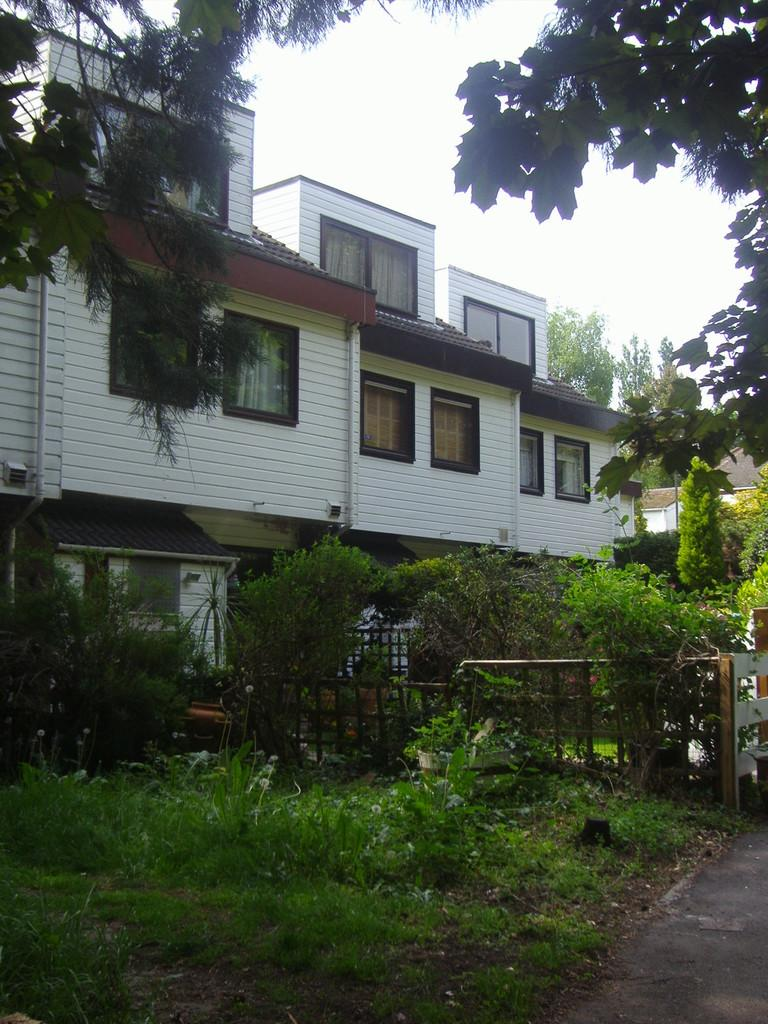What type of structure is present in the image? There is a building in the picture. What type of vegetation can be seen in the image? There is grass, plants, and trees in the picture. What is visible in the background of the image? The sky is visible in the background of the picture. Where is the bat located in the image? There is no bat present in the image. What type of tub can be seen in the image? There is no tub present in the image. 